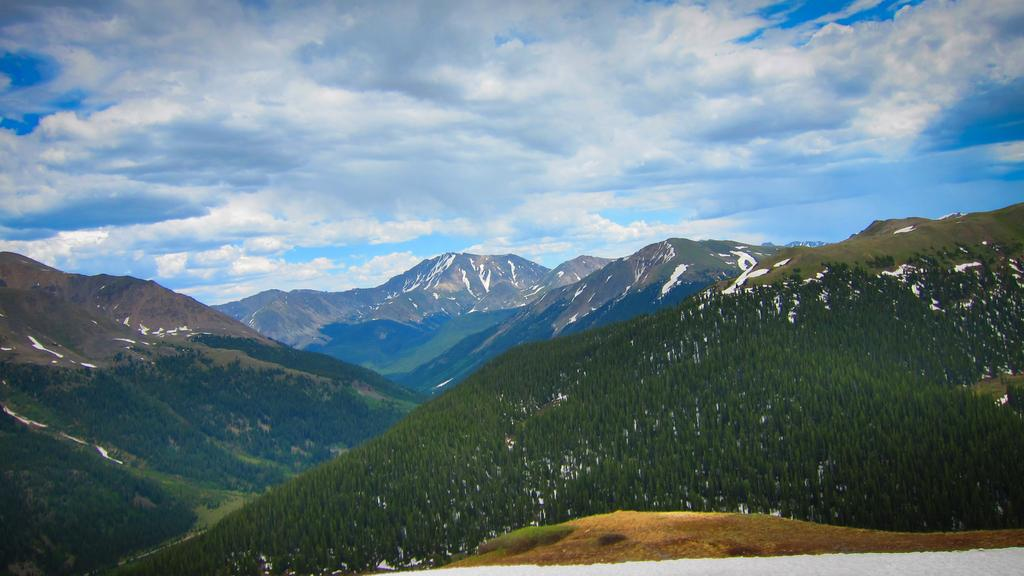What is the main subject in the center of the image? There are mountains in the center of the image. What type of root can be seen growing from the chair in the image? There is no chair or root present in the image; it only features mountains. 